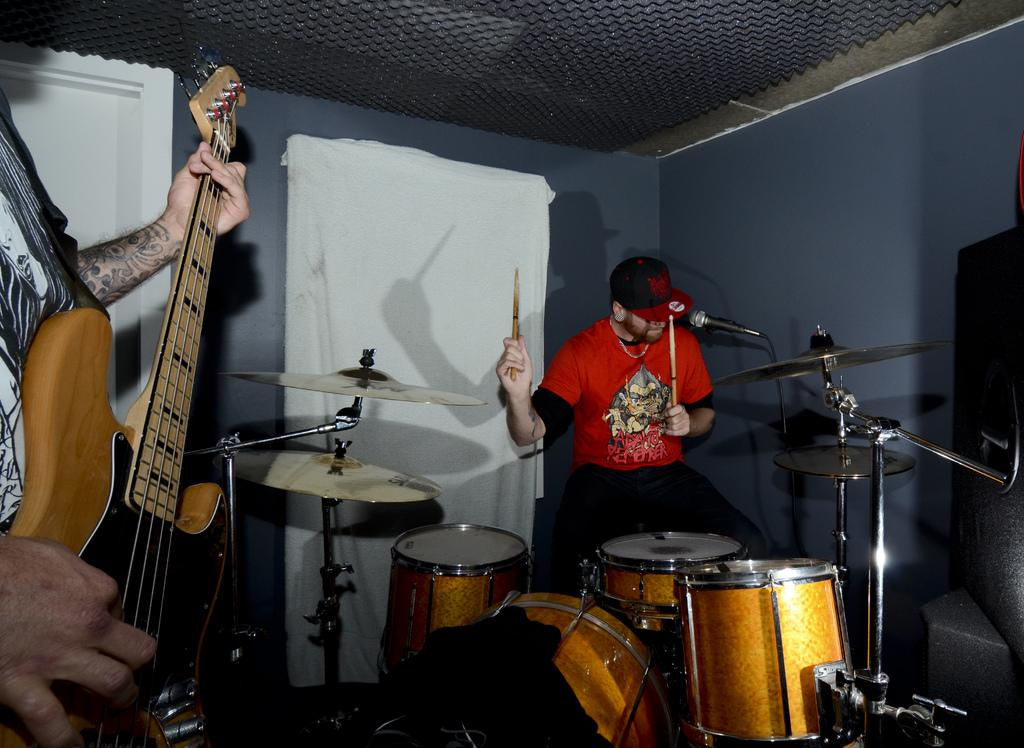What is the man in the image holding? The man is holding a guitar in the image. What instrument is the other person sitting next to? The other person is sitting next to a drum set in the image. Can you describe anything visible in the background of the image? Yes, there is a cloth visible in the background of the image. What type of flowers can be seen growing around the drum set in the image? There are no flowers visible in the image; the focus is on the man holding a guitar and the person sitting next to the drum set. 